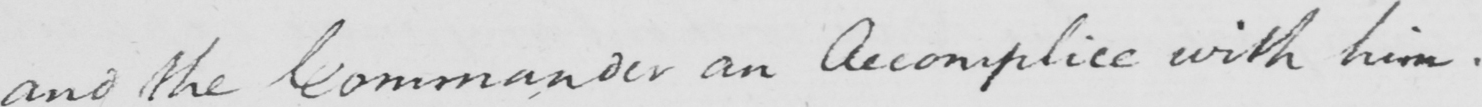Can you read and transcribe this handwriting? and the Commander an Accomplice with him . 